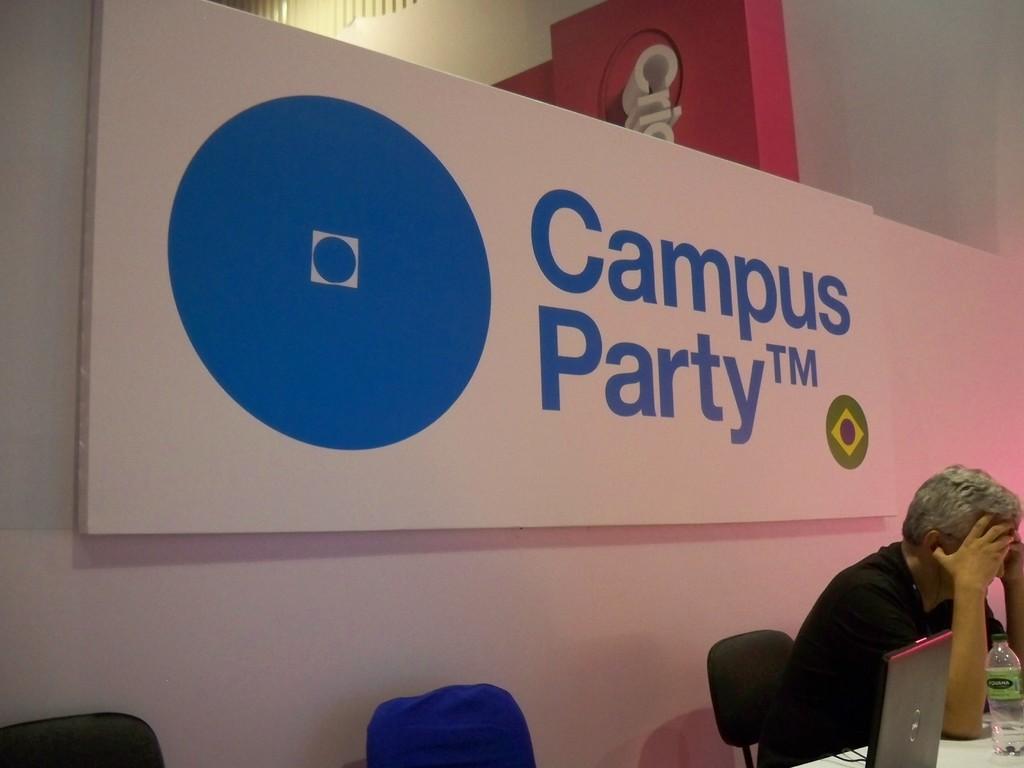How would you summarize this image in a sentence or two? In this image there is a name board with a patent rights and a trade mark and there is a person sitting in chair , there is laptop, bottle, table, chair. 